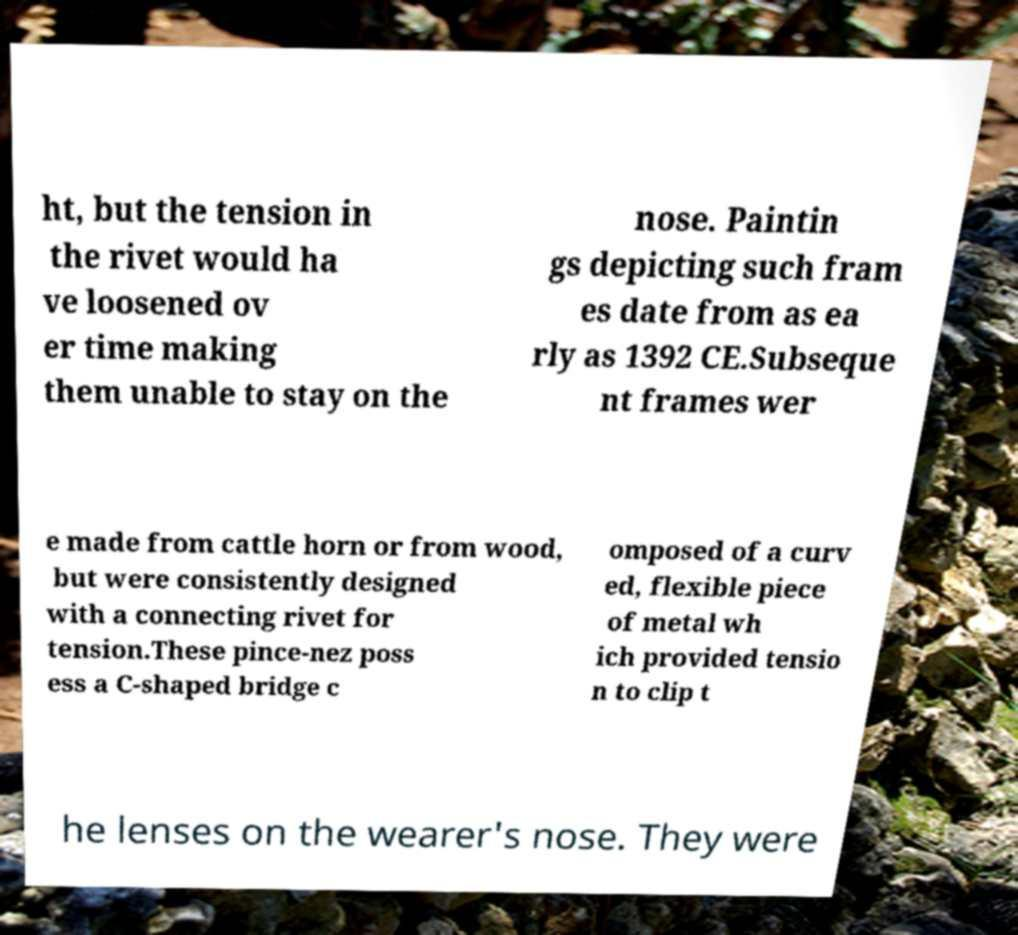Could you assist in decoding the text presented in this image and type it out clearly? ht, but the tension in the rivet would ha ve loosened ov er time making them unable to stay on the nose. Paintin gs depicting such fram es date from as ea rly as 1392 CE.Subseque nt frames wer e made from cattle horn or from wood, but were consistently designed with a connecting rivet for tension.These pince-nez poss ess a C-shaped bridge c omposed of a curv ed, flexible piece of metal wh ich provided tensio n to clip t he lenses on the wearer's nose. They were 